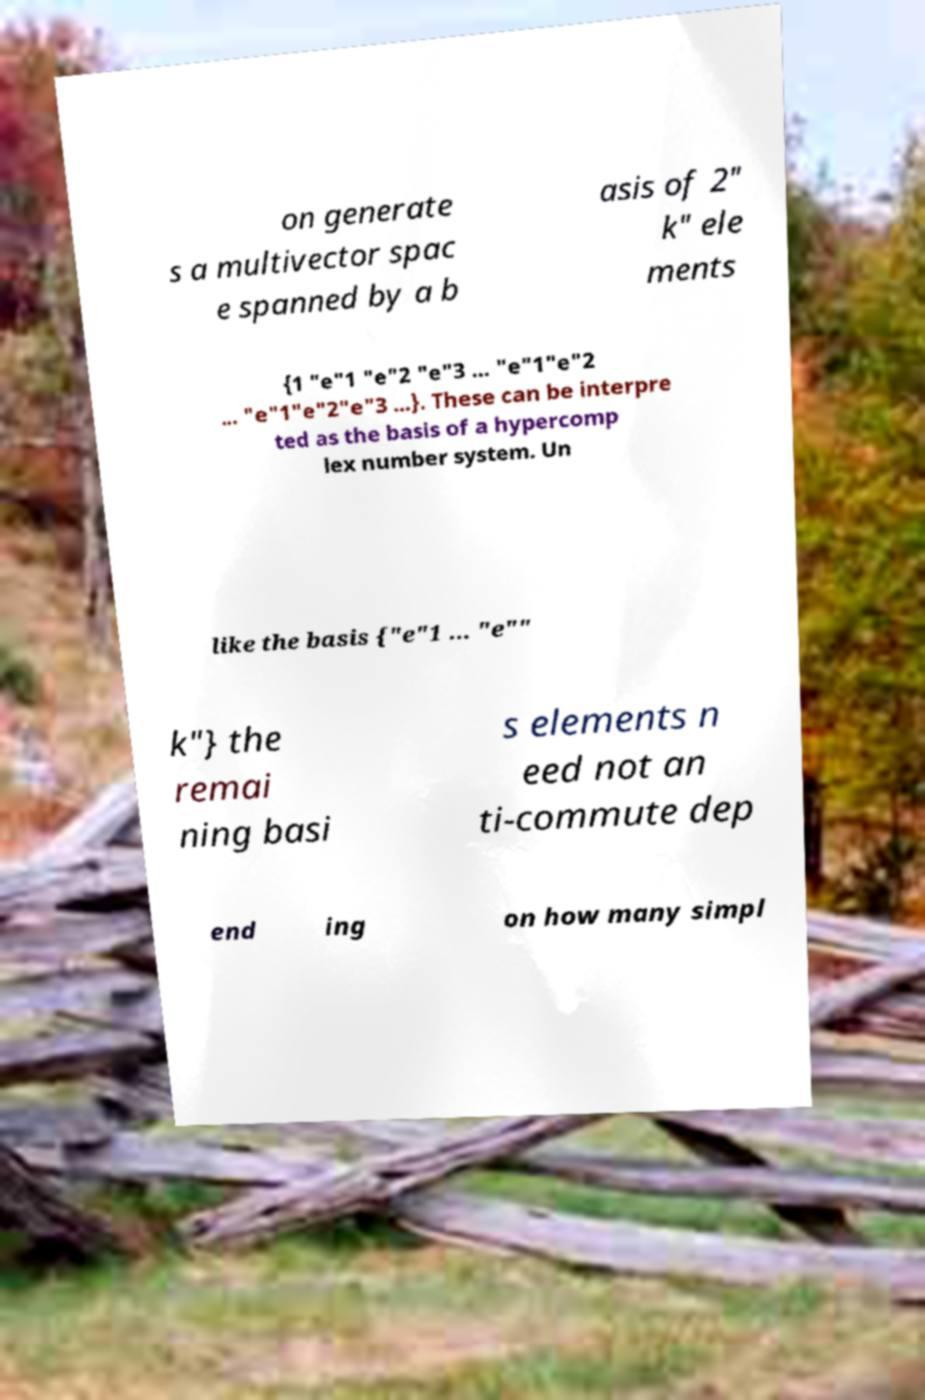What messages or text are displayed in this image? I need them in a readable, typed format. on generate s a multivector spac e spanned by a b asis of 2" k" ele ments {1 "e"1 "e"2 "e"3 ... "e"1"e"2 ... "e"1"e"2"e"3 ...}. These can be interpre ted as the basis of a hypercomp lex number system. Un like the basis {"e"1 ... "e"" k"} the remai ning basi s elements n eed not an ti-commute dep end ing on how many simpl 